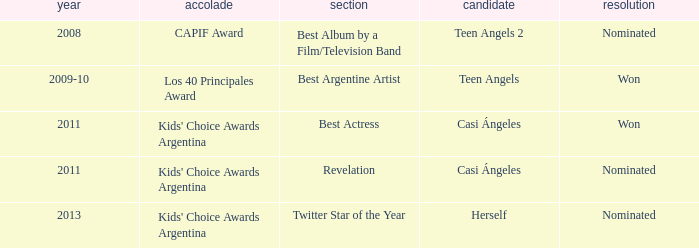What performance was nominated for a capif award? Teen Angels 2. 